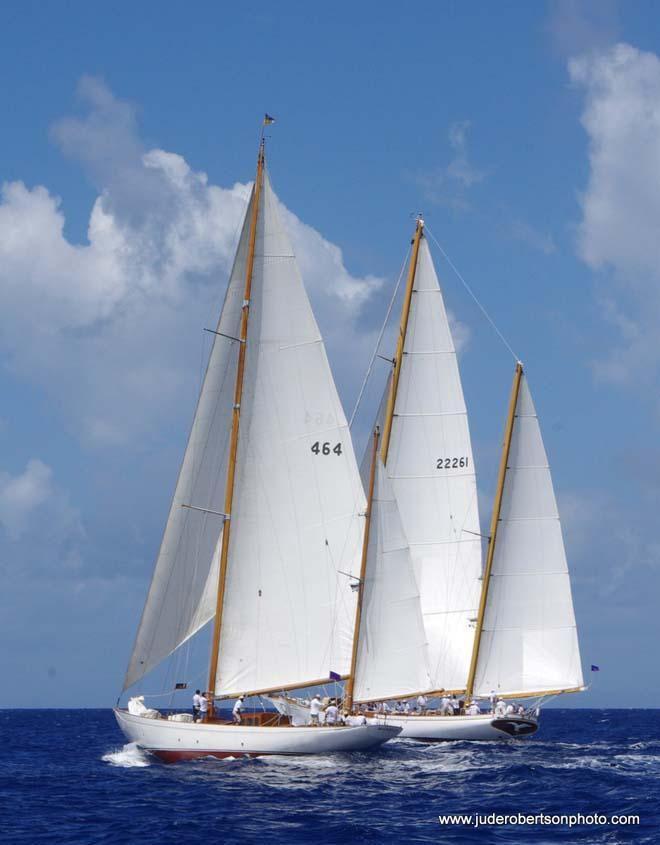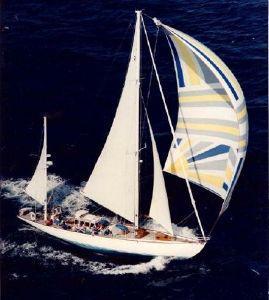The first image is the image on the left, the second image is the image on the right. Examine the images to the left and right. Is the description "A sailboat has only 1 large sail and 1 small sail unfurled." accurate? Answer yes or no. No. The first image is the image on the left, the second image is the image on the right. Evaluate the accuracy of this statement regarding the images: "A boat has exactly two sails.". Is it true? Answer yes or no. No. 